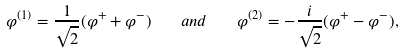<formula> <loc_0><loc_0><loc_500><loc_500>\varphi ^ { ( 1 ) } = \frac { 1 } { \sqrt { 2 } } ( \varphi ^ { + } + \varphi ^ { - } ) \quad a n d \quad \varphi ^ { ( 2 ) } = - \frac { i } { \sqrt { 2 } } ( \varphi ^ { + } - \varphi ^ { - } ) ,</formula> 